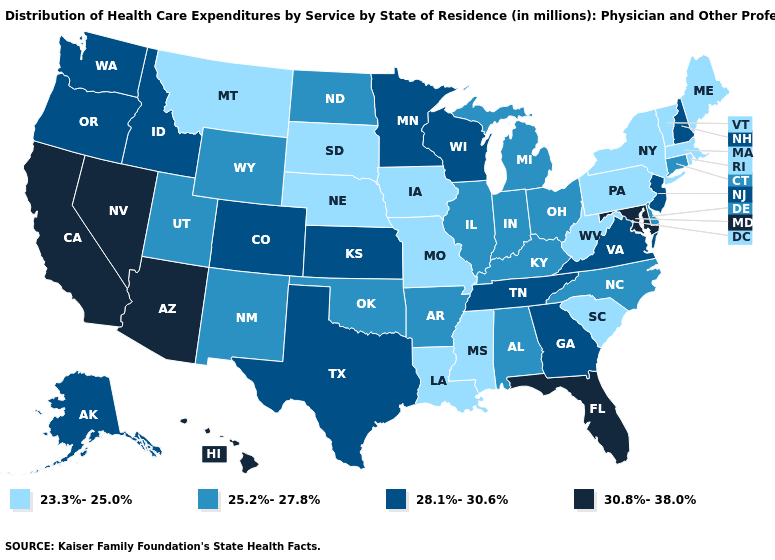Is the legend a continuous bar?
Answer briefly. No. What is the value of New Mexico?
Quick response, please. 25.2%-27.8%. What is the value of Connecticut?
Write a very short answer. 25.2%-27.8%. Does New Mexico have the lowest value in the USA?
Keep it brief. No. Among the states that border Maine , which have the lowest value?
Be succinct. New Hampshire. Does Kansas have the lowest value in the MidWest?
Keep it brief. No. What is the value of Massachusetts?
Answer briefly. 23.3%-25.0%. Which states have the lowest value in the USA?
Keep it brief. Iowa, Louisiana, Maine, Massachusetts, Mississippi, Missouri, Montana, Nebraska, New York, Pennsylvania, Rhode Island, South Carolina, South Dakota, Vermont, West Virginia. Name the states that have a value in the range 28.1%-30.6%?
Concise answer only. Alaska, Colorado, Georgia, Idaho, Kansas, Minnesota, New Hampshire, New Jersey, Oregon, Tennessee, Texas, Virginia, Washington, Wisconsin. Does Virginia have the highest value in the USA?
Keep it brief. No. What is the value of Minnesota?
Short answer required. 28.1%-30.6%. Does Michigan have the lowest value in the USA?
Quick response, please. No. What is the lowest value in the Northeast?
Give a very brief answer. 23.3%-25.0%. Name the states that have a value in the range 25.2%-27.8%?
Write a very short answer. Alabama, Arkansas, Connecticut, Delaware, Illinois, Indiana, Kentucky, Michigan, New Mexico, North Carolina, North Dakota, Ohio, Oklahoma, Utah, Wyoming. What is the value of Rhode Island?
Answer briefly. 23.3%-25.0%. 